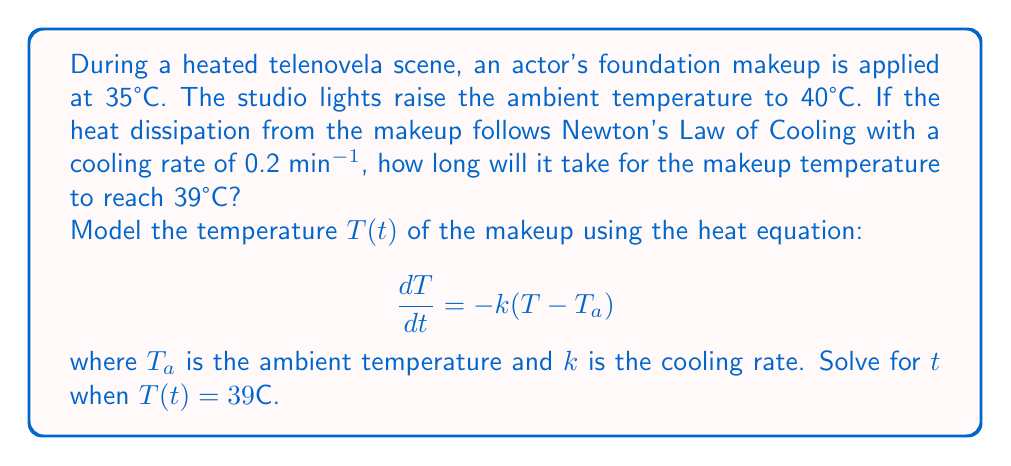Give your solution to this math problem. Let's approach this step-by-step:

1) The heat equation for Newton's Law of Cooling is:
   $$\frac{dT}{dt} = -k(T - T_a)$$

2) We're given:
   - Initial temperature $T_0 = 35°C$
   - Ambient temperature $T_a = 40°C$
   - Cooling rate $k = 0.2$ min⁻¹
   - Final temperature $T(t) = 39°C$

3) The solution to this differential equation is:
   $$T(t) = T_a + (T_0 - T_a)e^{-kt}$$

4) Substituting our known values:
   $$39 = 40 + (35 - 40)e^{-0.2t}$$

5) Simplify:
   $$39 = 40 - 5e^{-0.2t}$$

6) Subtract 40 from both sides:
   $$-1 = -5e^{-0.2t}$$

7) Divide both sides by -5:
   $$0.2 = e^{-0.2t}$$

8) Take the natural log of both sides:
   $$\ln(0.2) = -0.2t$$

9) Solve for t:
   $$t = -\frac{\ln(0.2)}{0.2} \approx 8.047$$

Therefore, it will take approximately 8.047 minutes for the makeup to reach 39°C.
Answer: 8.047 minutes 